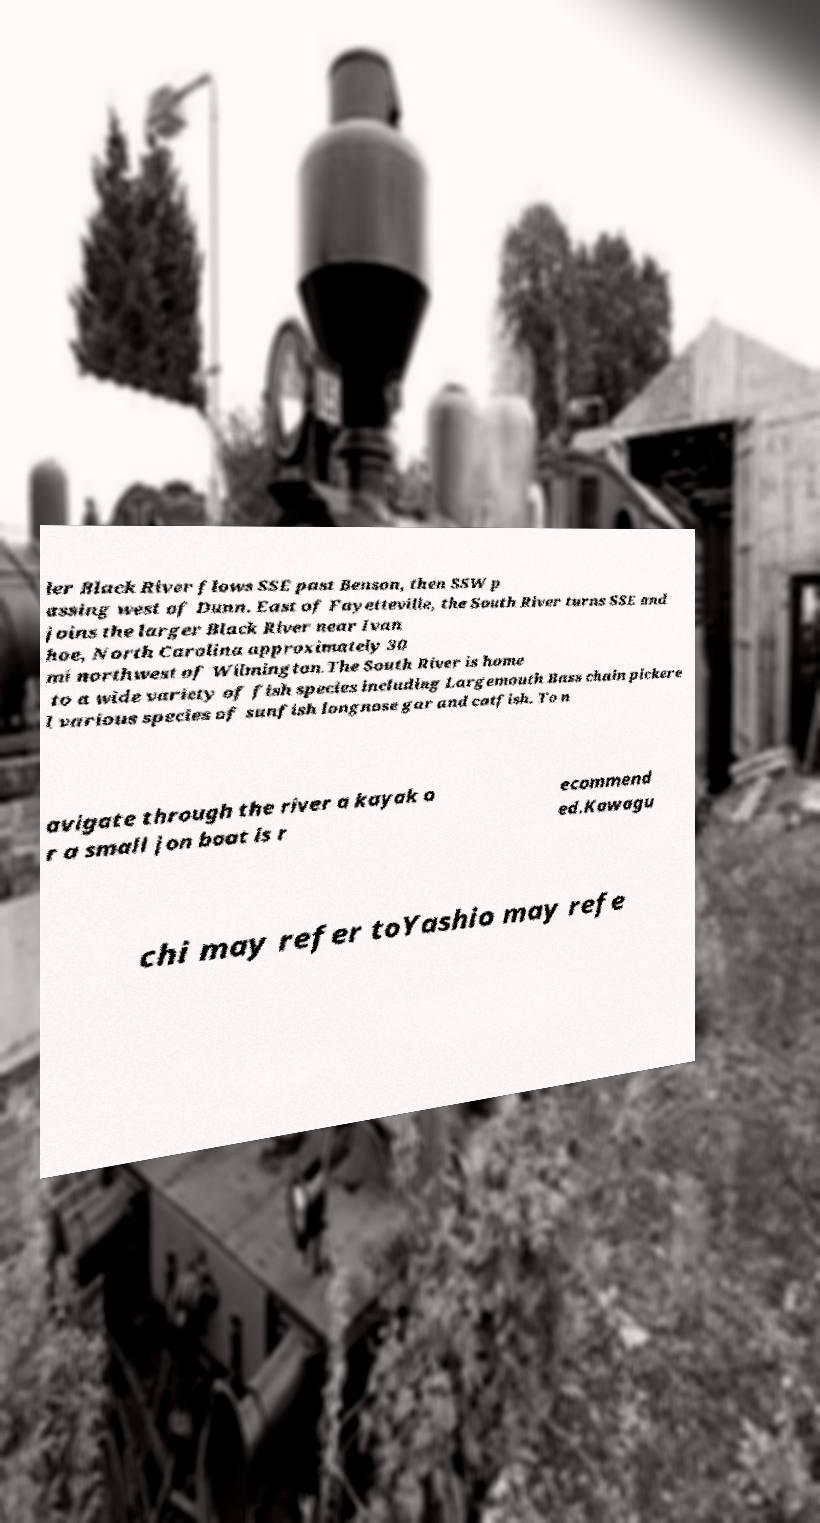For documentation purposes, I need the text within this image transcribed. Could you provide that? ler Black River flows SSE past Benson, then SSW p assing west of Dunn. East of Fayetteville, the South River turns SSE and joins the larger Black River near Ivan hoe, North Carolina approximately 30 mi northwest of Wilmington.The South River is home to a wide variety of fish species including Largemouth Bass chain pickere l various species of sunfish longnose gar and catfish. To n avigate through the river a kayak o r a small jon boat is r ecommend ed.Kawagu chi may refer toYashio may refe 